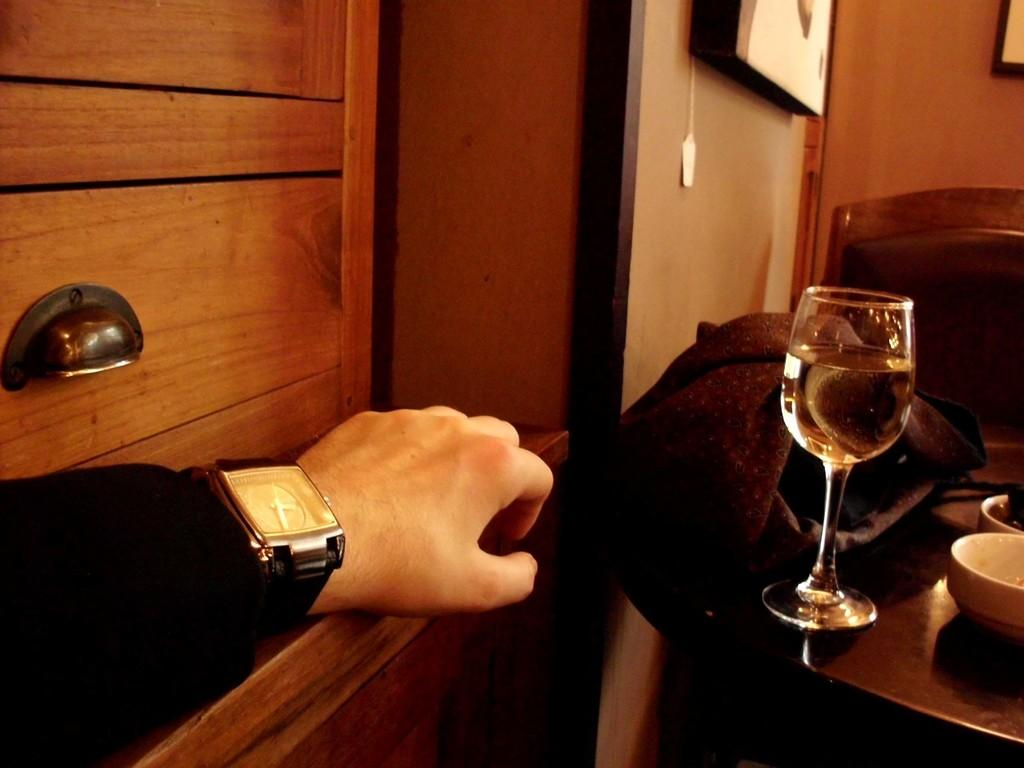What part of a person can be seen in the image? There is a person's hand in the image. What is the person holding in the image? There is a glass with a drink in the image. What type of material is present in the image? There is a cloth in the image. What type of containers are visible in the image? There are bowls in the image. Can you describe any other objects in the image? There are other objects in the image, but their specific details are not mentioned in the provided facts. What can be seen on the wall in the background of the image? There is a frame on the wall in the background of the image. What type of record is being played in the image? There is no record present in the image. What force is being applied to the glass in the image? The provided facts do not mention any force being applied to the glass in the image. 